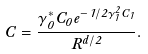<formula> <loc_0><loc_0><loc_500><loc_500>C = \frac { \gamma _ { 0 } ^ { * } C _ { 0 } e ^ { - 1 / 2 \gamma _ { 1 } ^ { 2 } C _ { 1 } } } { R ^ { d / 2 } } .</formula> 